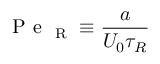Convert formula to latex. <formula><loc_0><loc_0><loc_500><loc_500>P e _ { R } \equiv \frac { a } { U _ { 0 } \tau _ { R } }</formula> 